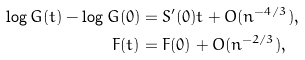Convert formula to latex. <formula><loc_0><loc_0><loc_500><loc_500>\log G ( t ) - \log G ( 0 ) & = S ^ { \prime } ( 0 ) t + O ( n ^ { - 4 / 3 } ) , \\ F ( t ) & = F ( 0 ) + O ( n ^ { - 2 / 3 } ) ,</formula> 